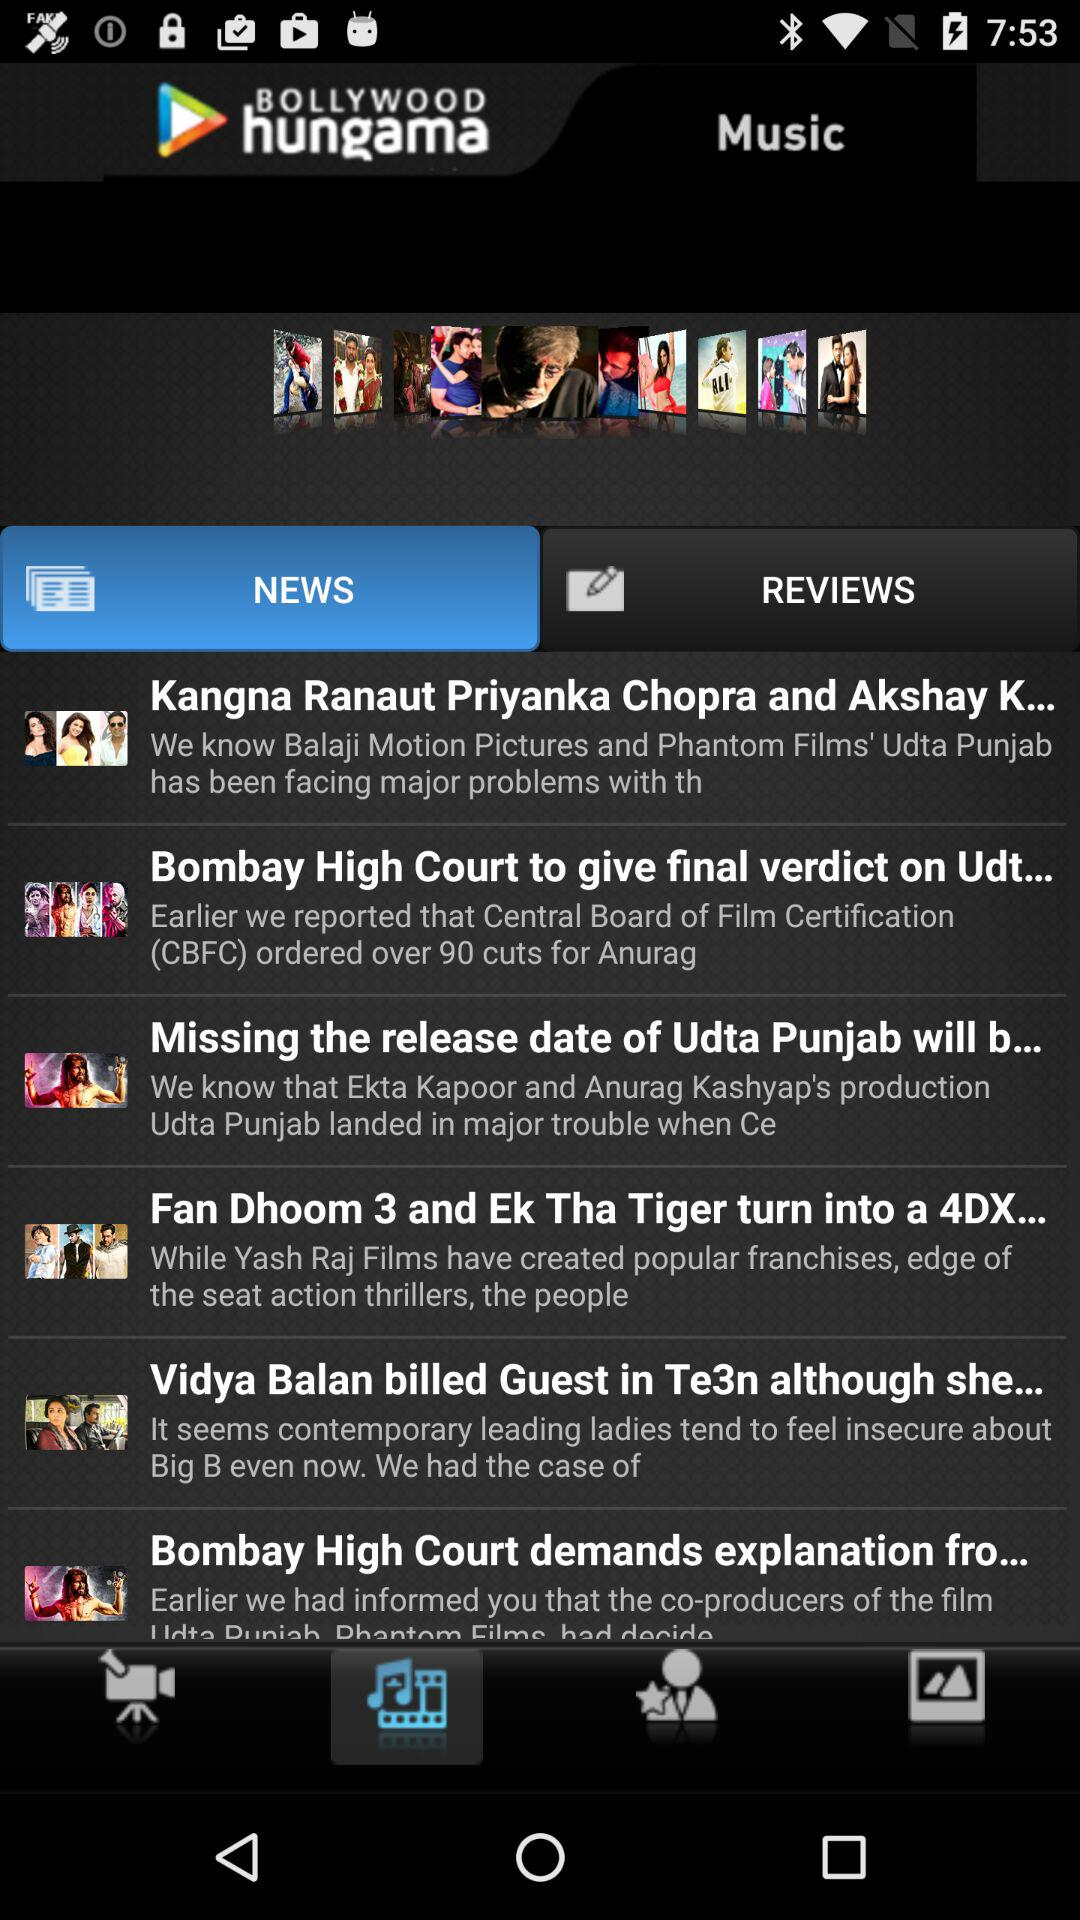What is the name of the application? The application name is "BOLLYWOOD hungama". 